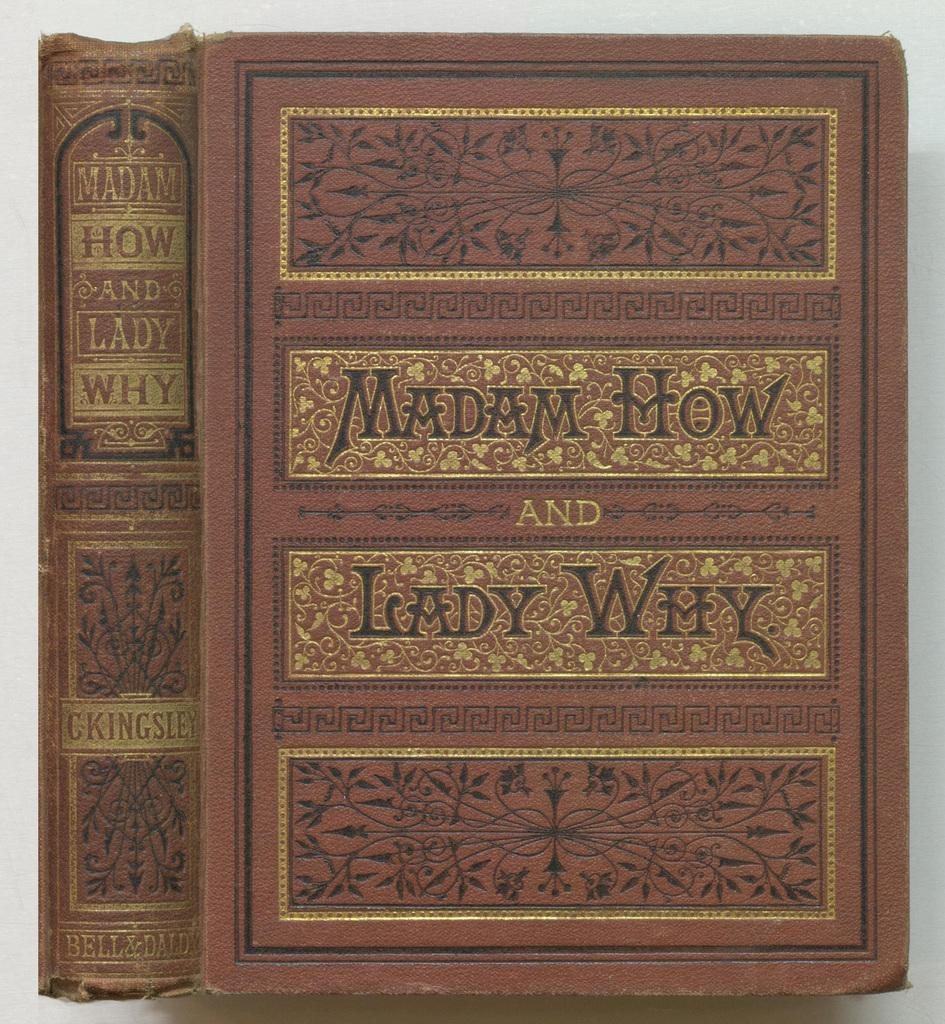<image>
Create a compact narrative representing the image presented. Fancy looking brown book titled "Madam How And Lady Why". 